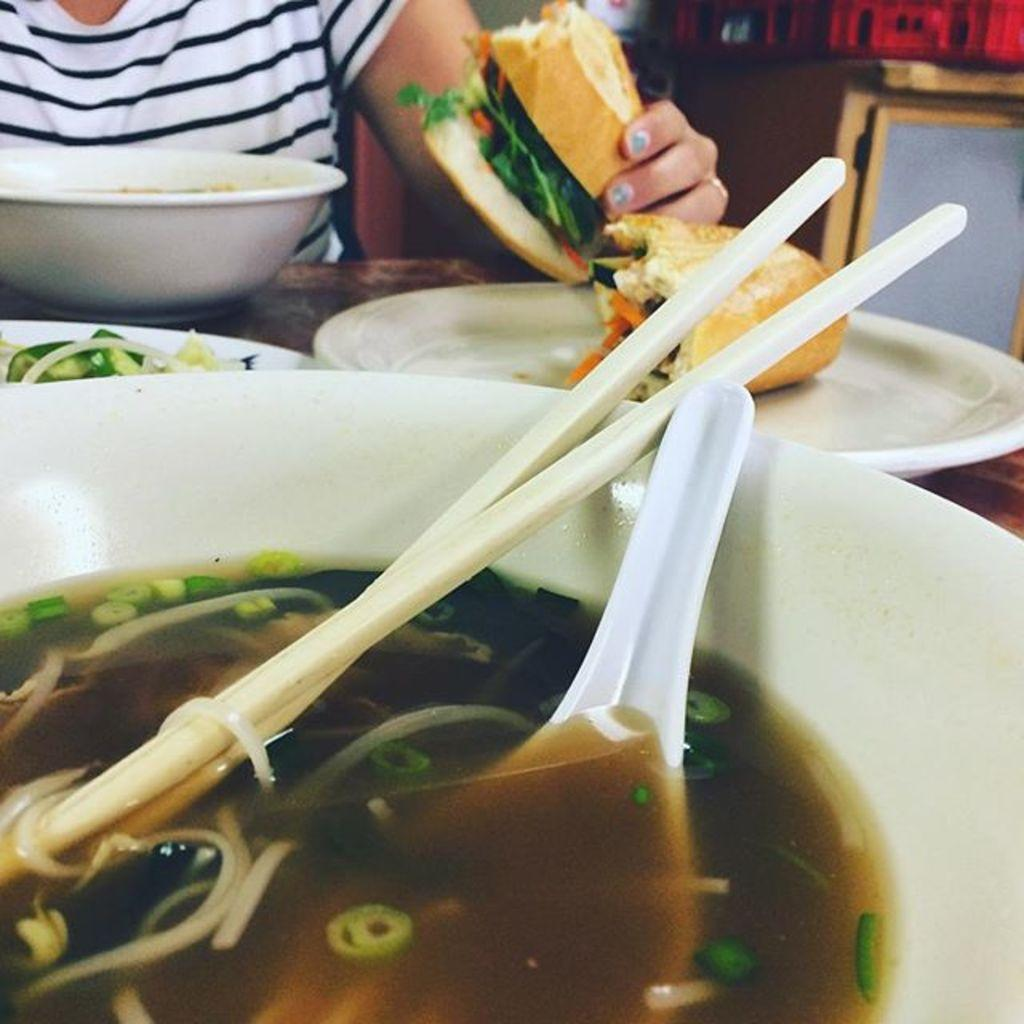What is the person in the image holding? The person is holding a burger. What is on the table in front of the person? There is a table in front of the person, with a bowl, a plate, and some utensils on it. What is in the bowl on the table? There is soup in the bowl, along with chopsticks and a spoon. What type of secretary is sitting next to the person in the image? There is no secretary present in the image. 